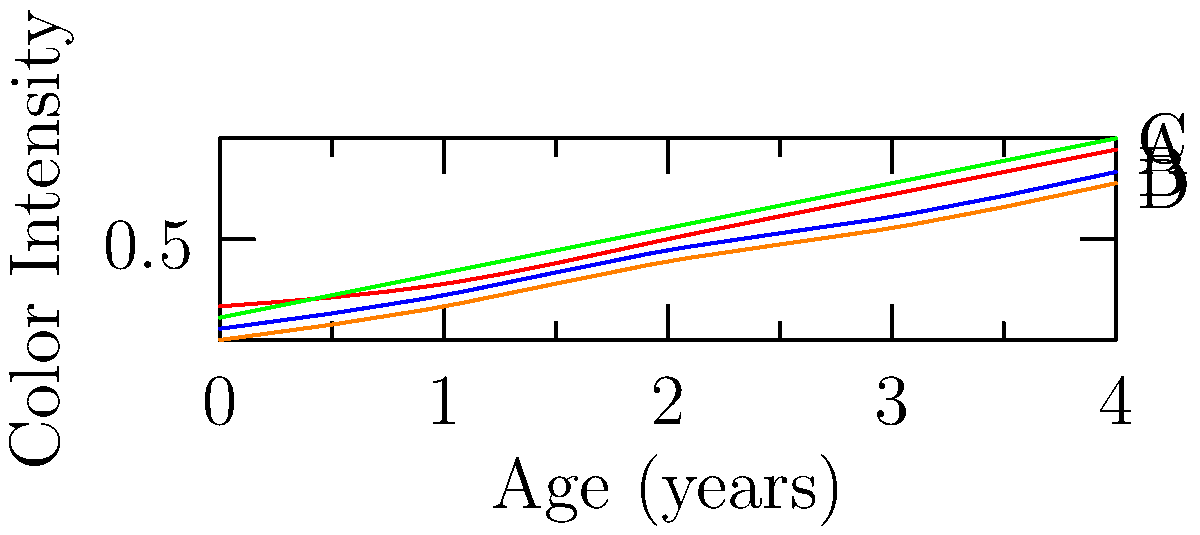The graph shows the color intensity development of four different whiskeys (A, B, C, and D) over a 4-year aging period. Which whiskey is likely to be a high-end, premium product based on its color development pattern? To determine which whiskey is likely to be a high-end, premium product, we need to analyze the color intensity development patterns:

1. Color intensity is an important indicator of whiskey quality and age.
2. Premium whiskeys typically develop a richer, more intense color over time.
3. Examining the graph:
   - Whiskey A (red) shows a steady increase in color intensity, reaching the highest point after 4 years.
   - Whiskey B (blue) has a moderate increase but doesn't reach the same intensity as A.
   - Whiskey C (green) shows the most rapid increase in color intensity, surpassing all others by the 4-year mark.
   - Whiskey D (orange) has the slowest color development, indicating it may be a lower-quality product.
4. The whiskey with the most rapid and significant color development is likely to be the premium product.
5. Whiskey C demonstrates the most dramatic increase in color intensity over the 4-year period, reaching the highest point by the end of the aging process.

Therefore, Whiskey C is most likely to be a high-end, premium product based on its color development pattern.
Answer: Whiskey C 